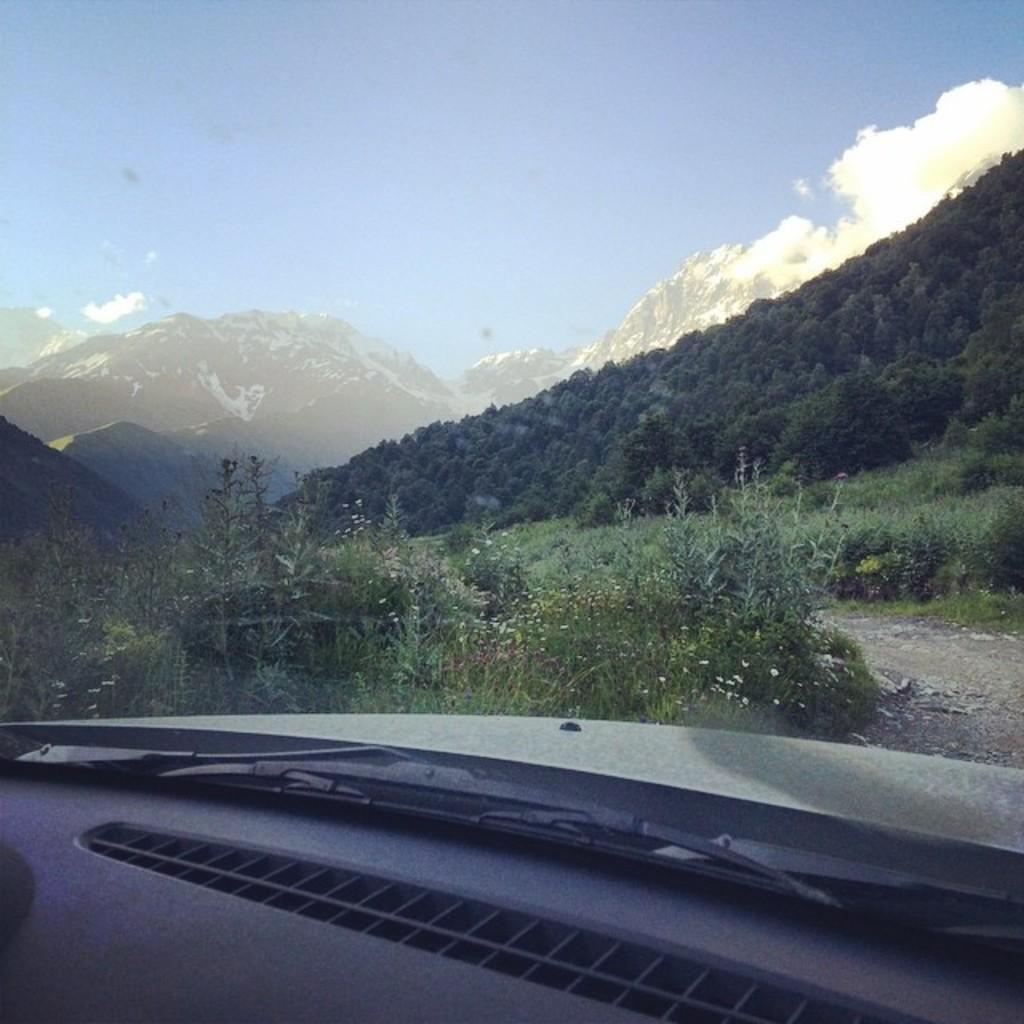What is the main subject of the image? There is a car in the image. What other natural elements can be seen in the image? There are plants, trees, and mountains visible in the image. What is visible in the sky in the image? The sky is visible in the image. Can you describe the setting of the image? The image may have been taken near a hill station. What type of stamp can be seen on the car in the image? There is no stamp visible on the car in the image. Can you describe the basket that is hanging from the tree in the image? There is no basket hanging from the tree in the image. 